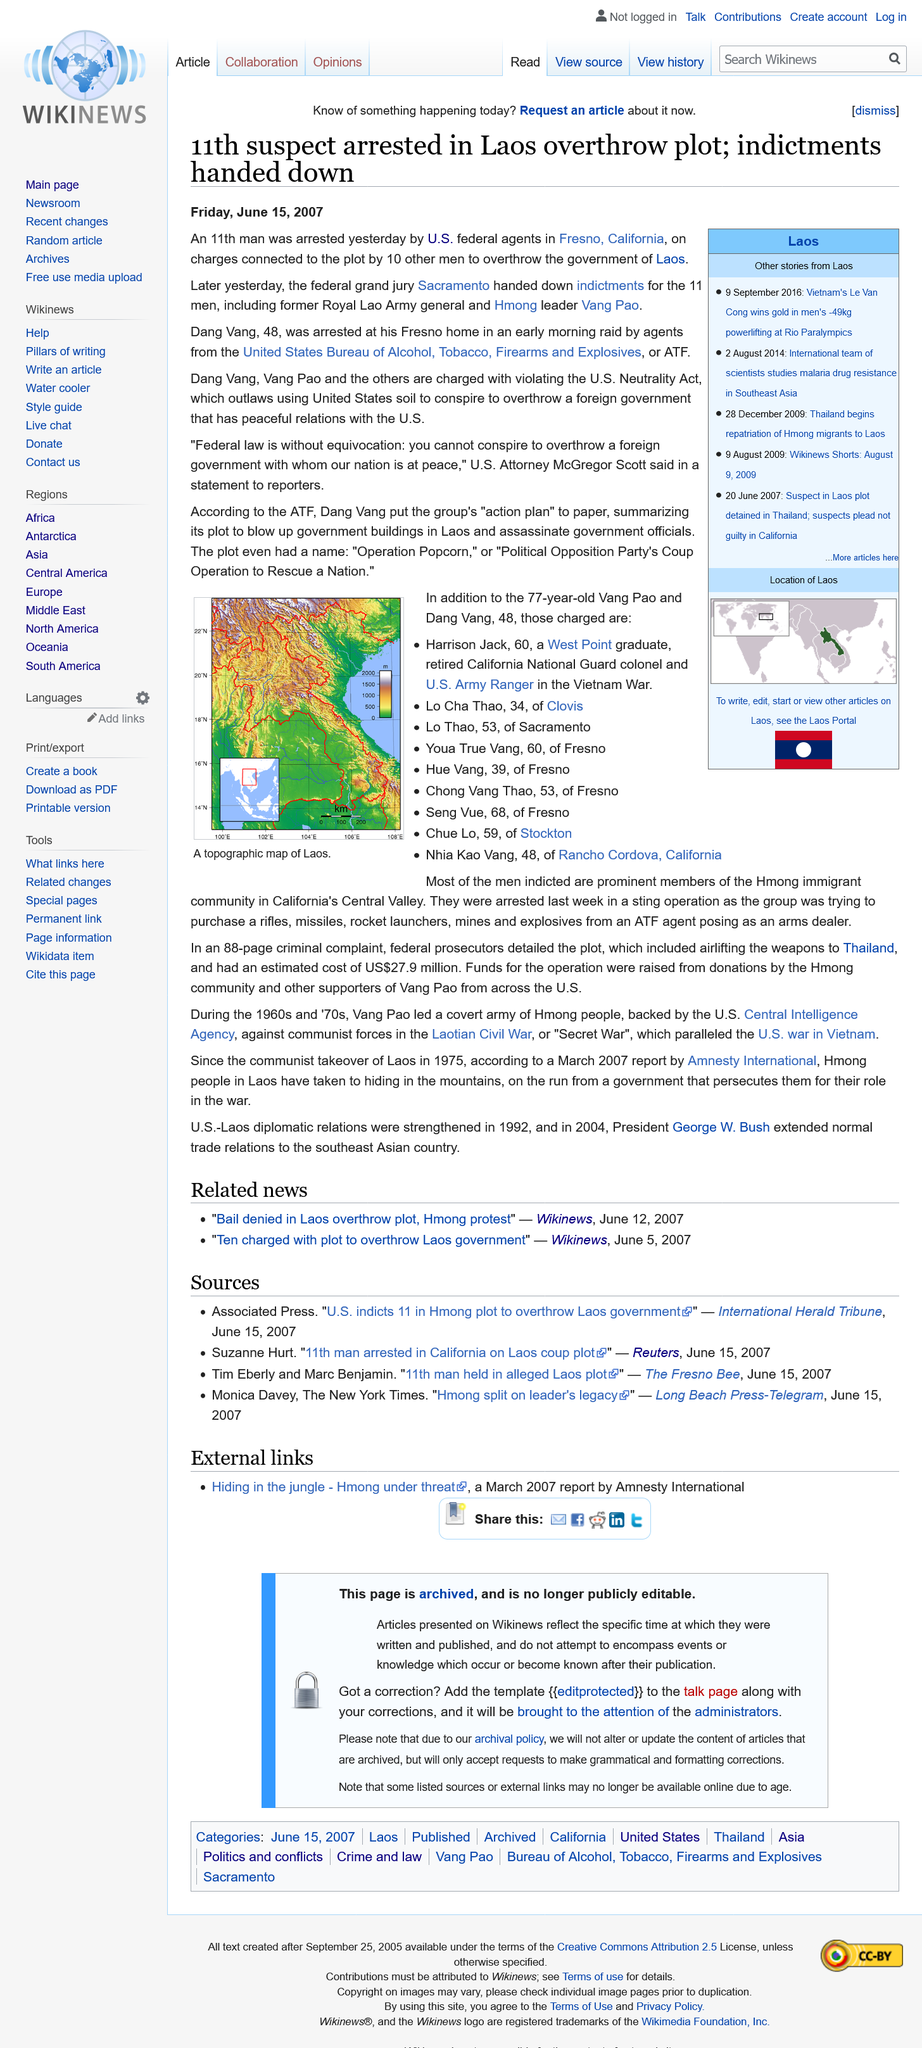List a handful of essential elements in this visual. Vang Pao was a former Royal Lao Army general and Hmong leader who was known for his leadership and military strategies during the Laotian Civil War. Dang Vang was arrested and charged with involvement in a plot to overthrow the government of Laos. Dang Vang was arrested at a Fresno home. 